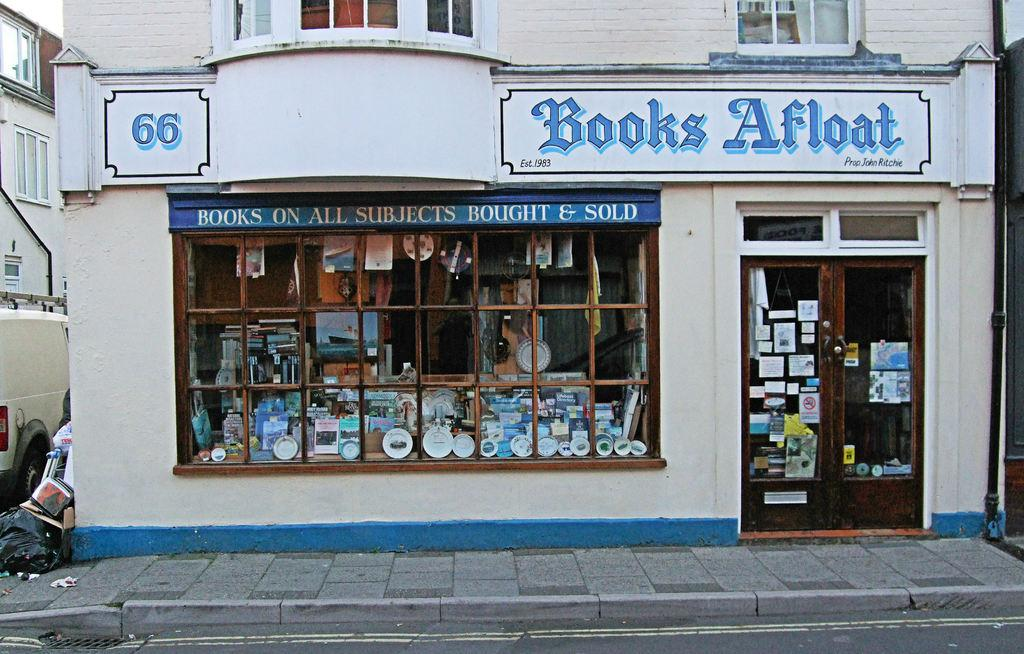<image>
Render a clear and concise summary of the photo. a store with a blue title that is called Books Afloat 